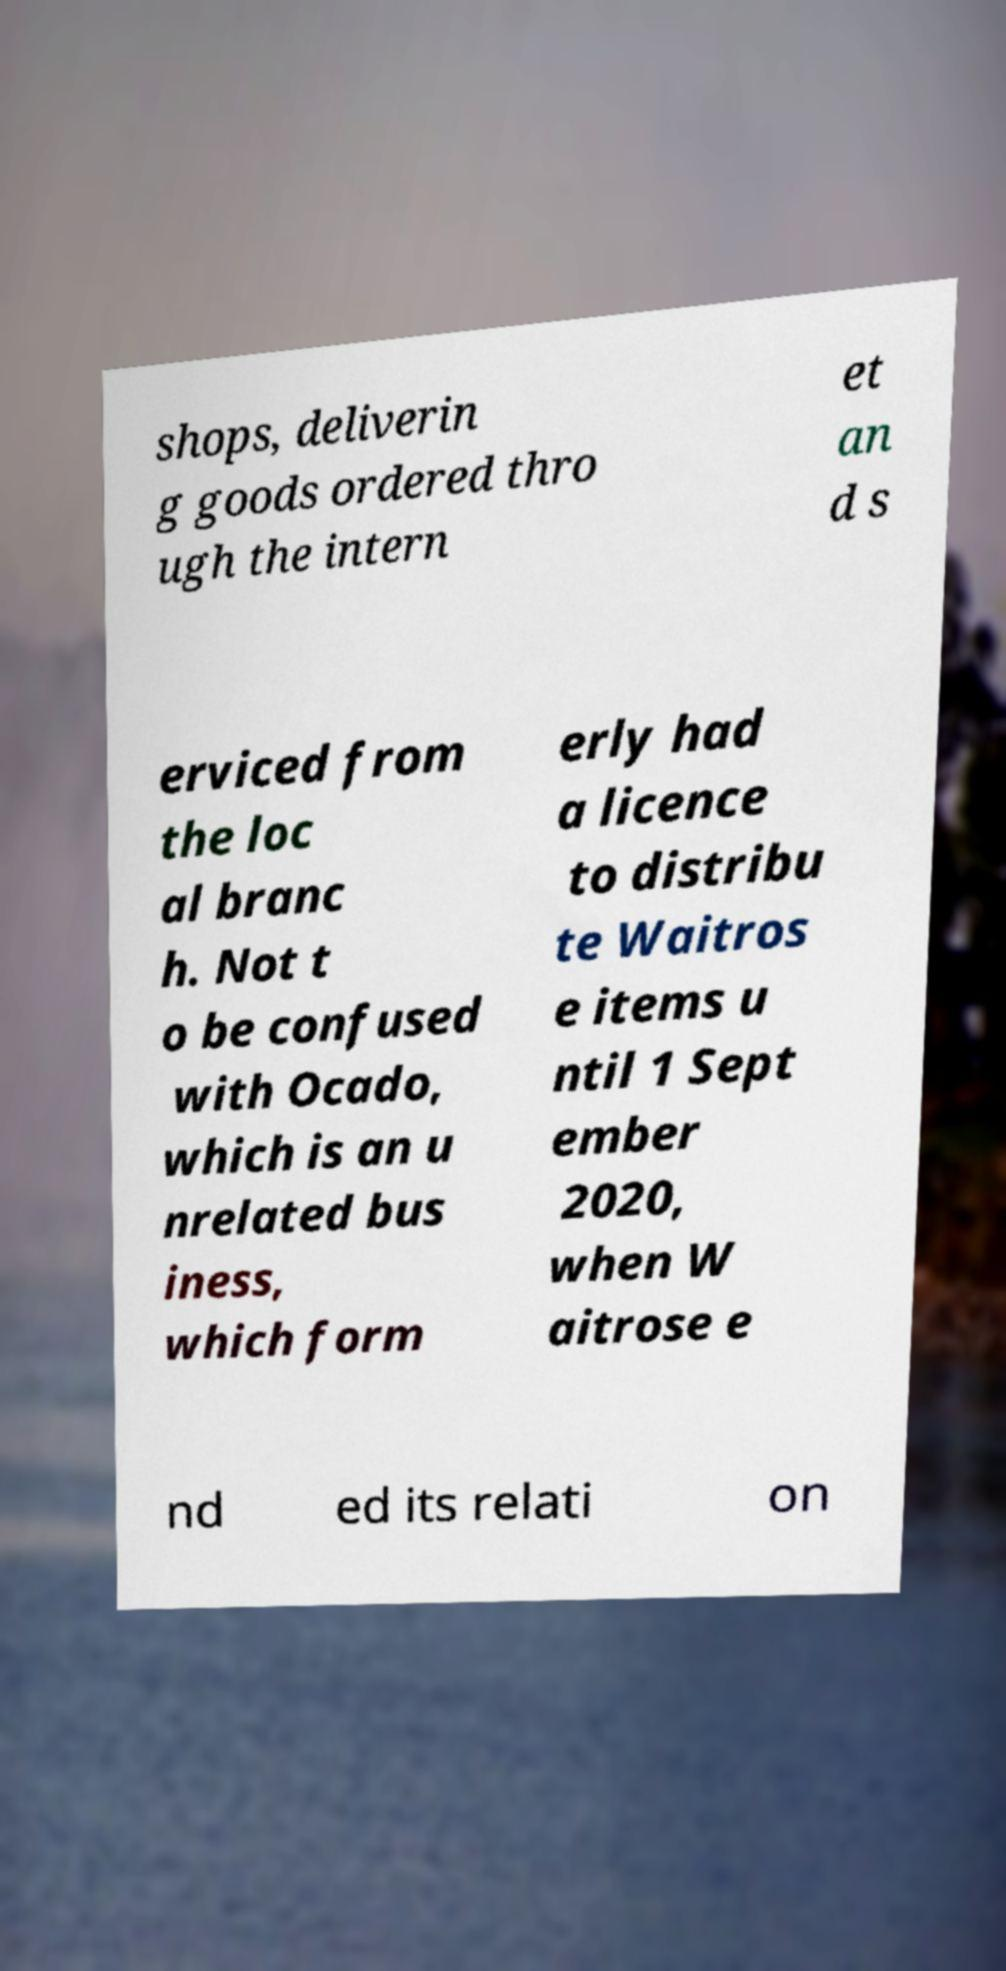Can you accurately transcribe the text from the provided image for me? shops, deliverin g goods ordered thro ugh the intern et an d s erviced from the loc al branc h. Not t o be confused with Ocado, which is an u nrelated bus iness, which form erly had a licence to distribu te Waitros e items u ntil 1 Sept ember 2020, when W aitrose e nd ed its relati on 